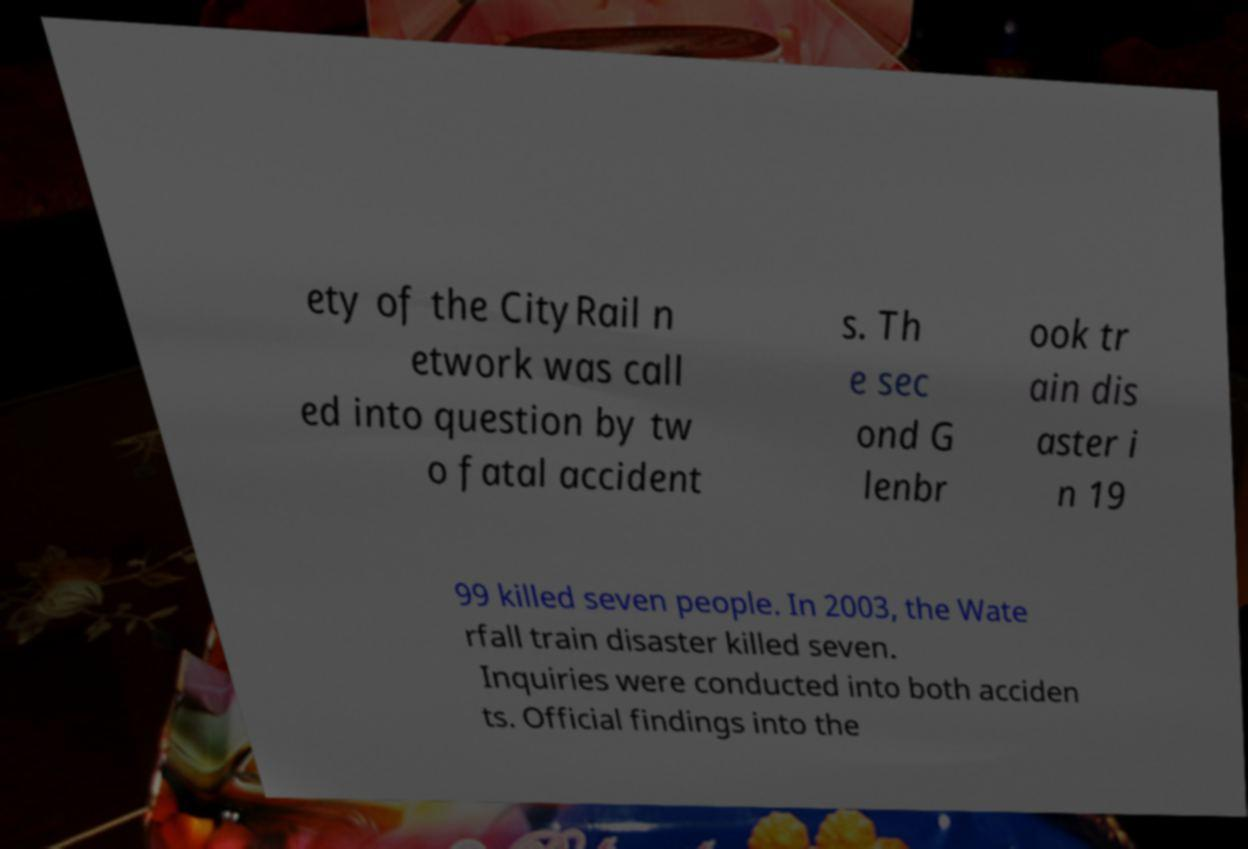Please identify and transcribe the text found in this image. ety of the CityRail n etwork was call ed into question by tw o fatal accident s. Th e sec ond G lenbr ook tr ain dis aster i n 19 99 killed seven people. In 2003, the Wate rfall train disaster killed seven. Inquiries were conducted into both acciden ts. Official findings into the 